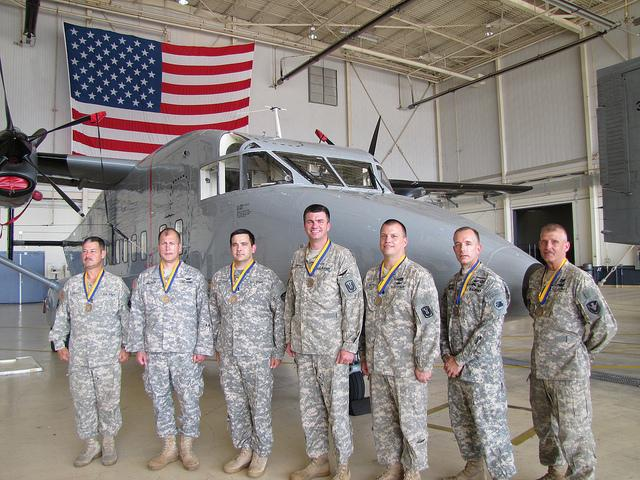How do the people know each other? Please explain your reasoning. coworkers. The men are all military colleagues. 